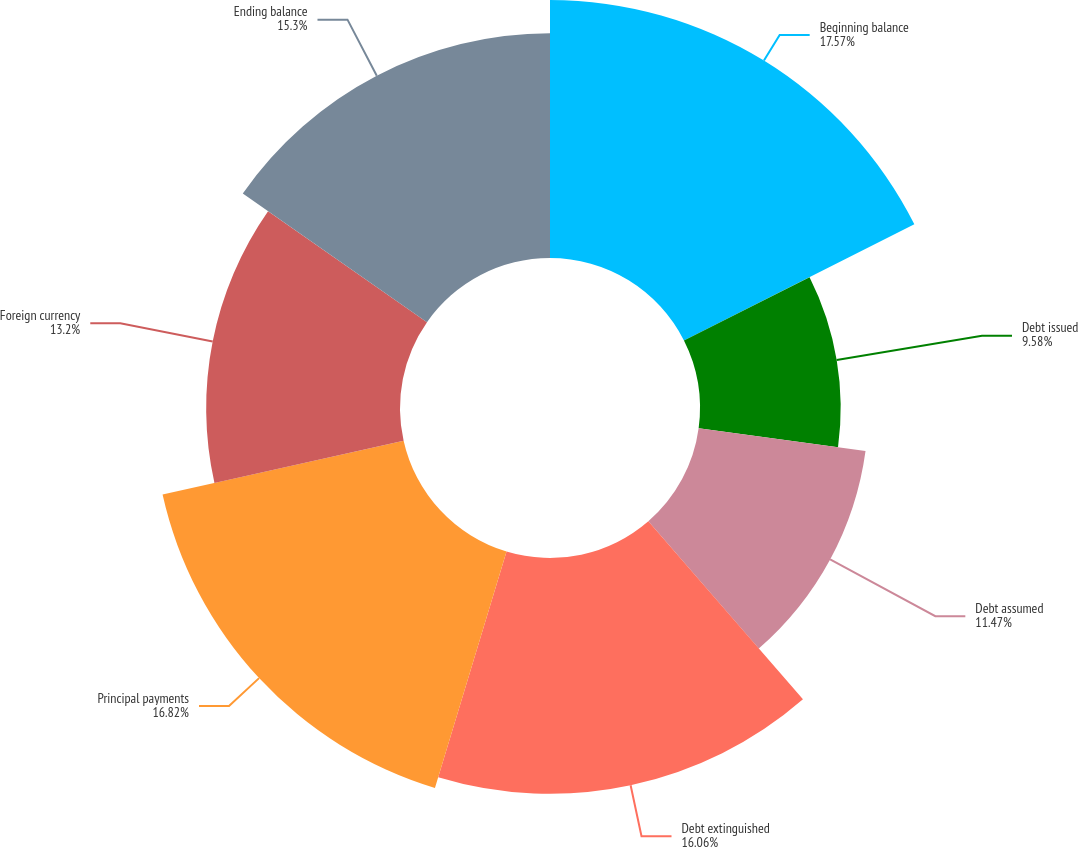Convert chart. <chart><loc_0><loc_0><loc_500><loc_500><pie_chart><fcel>Beginning balance<fcel>Debt issued<fcel>Debt assumed<fcel>Debt extinguished<fcel>Principal payments<fcel>Foreign currency<fcel>Ending balance<nl><fcel>17.57%<fcel>9.58%<fcel>11.47%<fcel>16.06%<fcel>16.82%<fcel>13.2%<fcel>15.3%<nl></chart> 